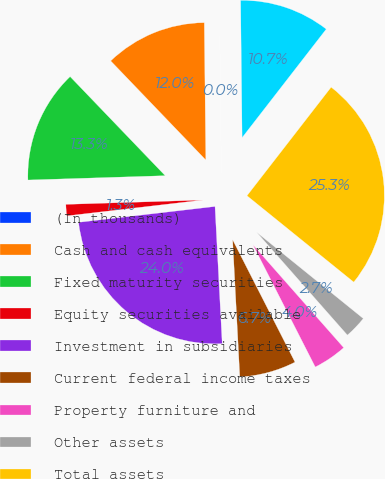Convert chart to OTSL. <chart><loc_0><loc_0><loc_500><loc_500><pie_chart><fcel>(In thousands)<fcel>Cash and cash equivalents<fcel>Fixed maturity securities<fcel>Equity securities available<fcel>Investment in subsidiaries<fcel>Current federal income taxes<fcel>Property furniture and<fcel>Other assets<fcel>Total assets<fcel>Due to subsidiaries<nl><fcel>0.0%<fcel>12.0%<fcel>13.33%<fcel>1.34%<fcel>23.99%<fcel>6.67%<fcel>4.0%<fcel>2.67%<fcel>25.33%<fcel>10.67%<nl></chart> 